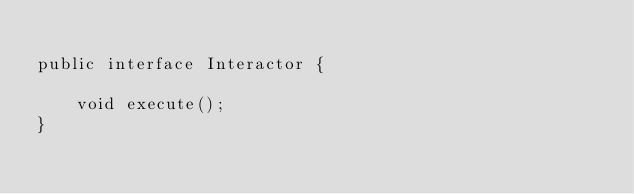<code> <loc_0><loc_0><loc_500><loc_500><_Java_>
public interface Interactor {

    void execute();
}
</code> 